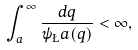<formula> <loc_0><loc_0><loc_500><loc_500>\int _ { a } ^ { \infty } \frac { d q } { \psi _ { \L } a ( q ) } < \infty ,</formula> 